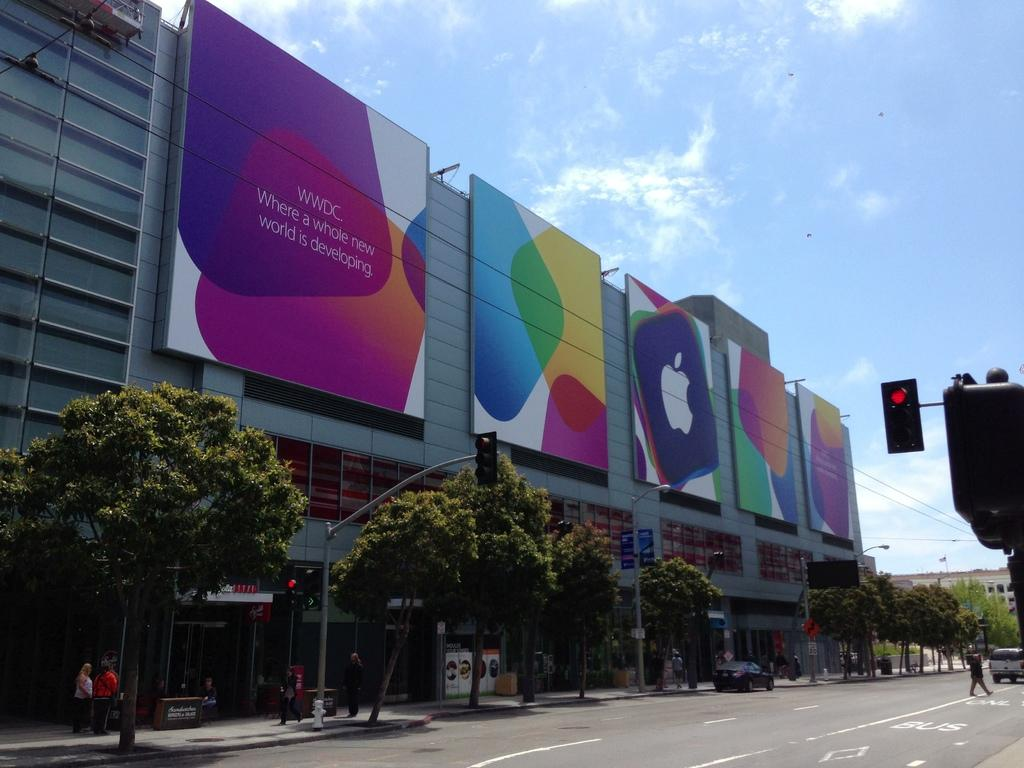<image>
Summarize the visual content of the image. Street with a building that has a sign with the letters "WWDC" on it. 